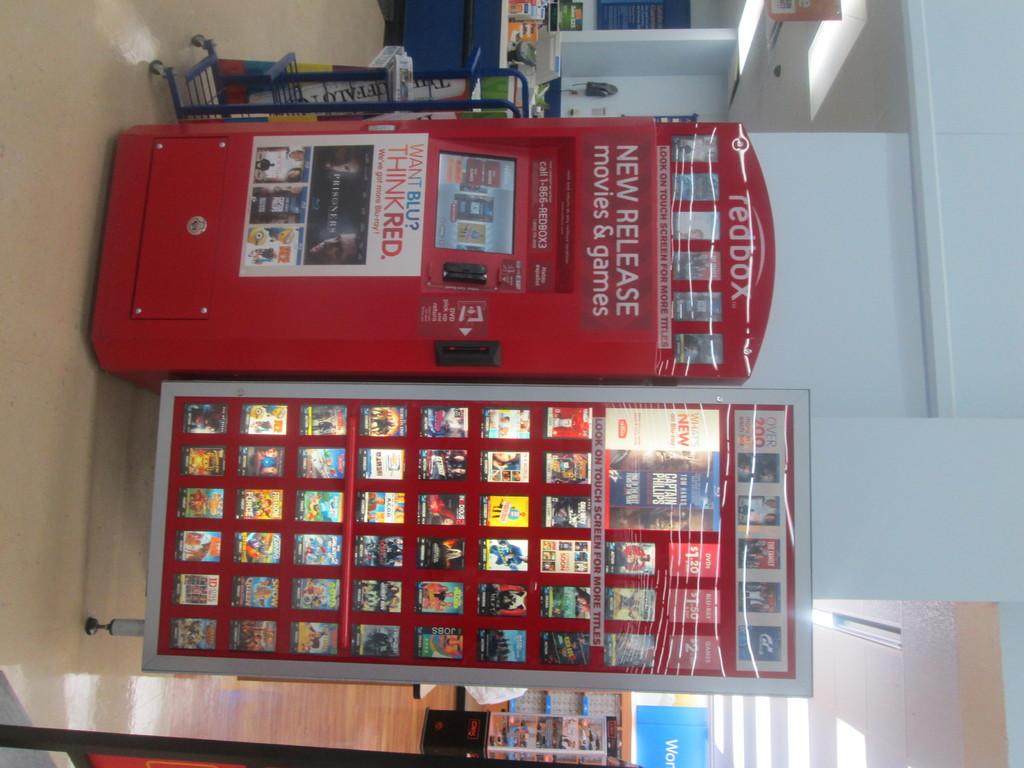What types of products does the redbox have?
Provide a succinct answer. Movies and games. 